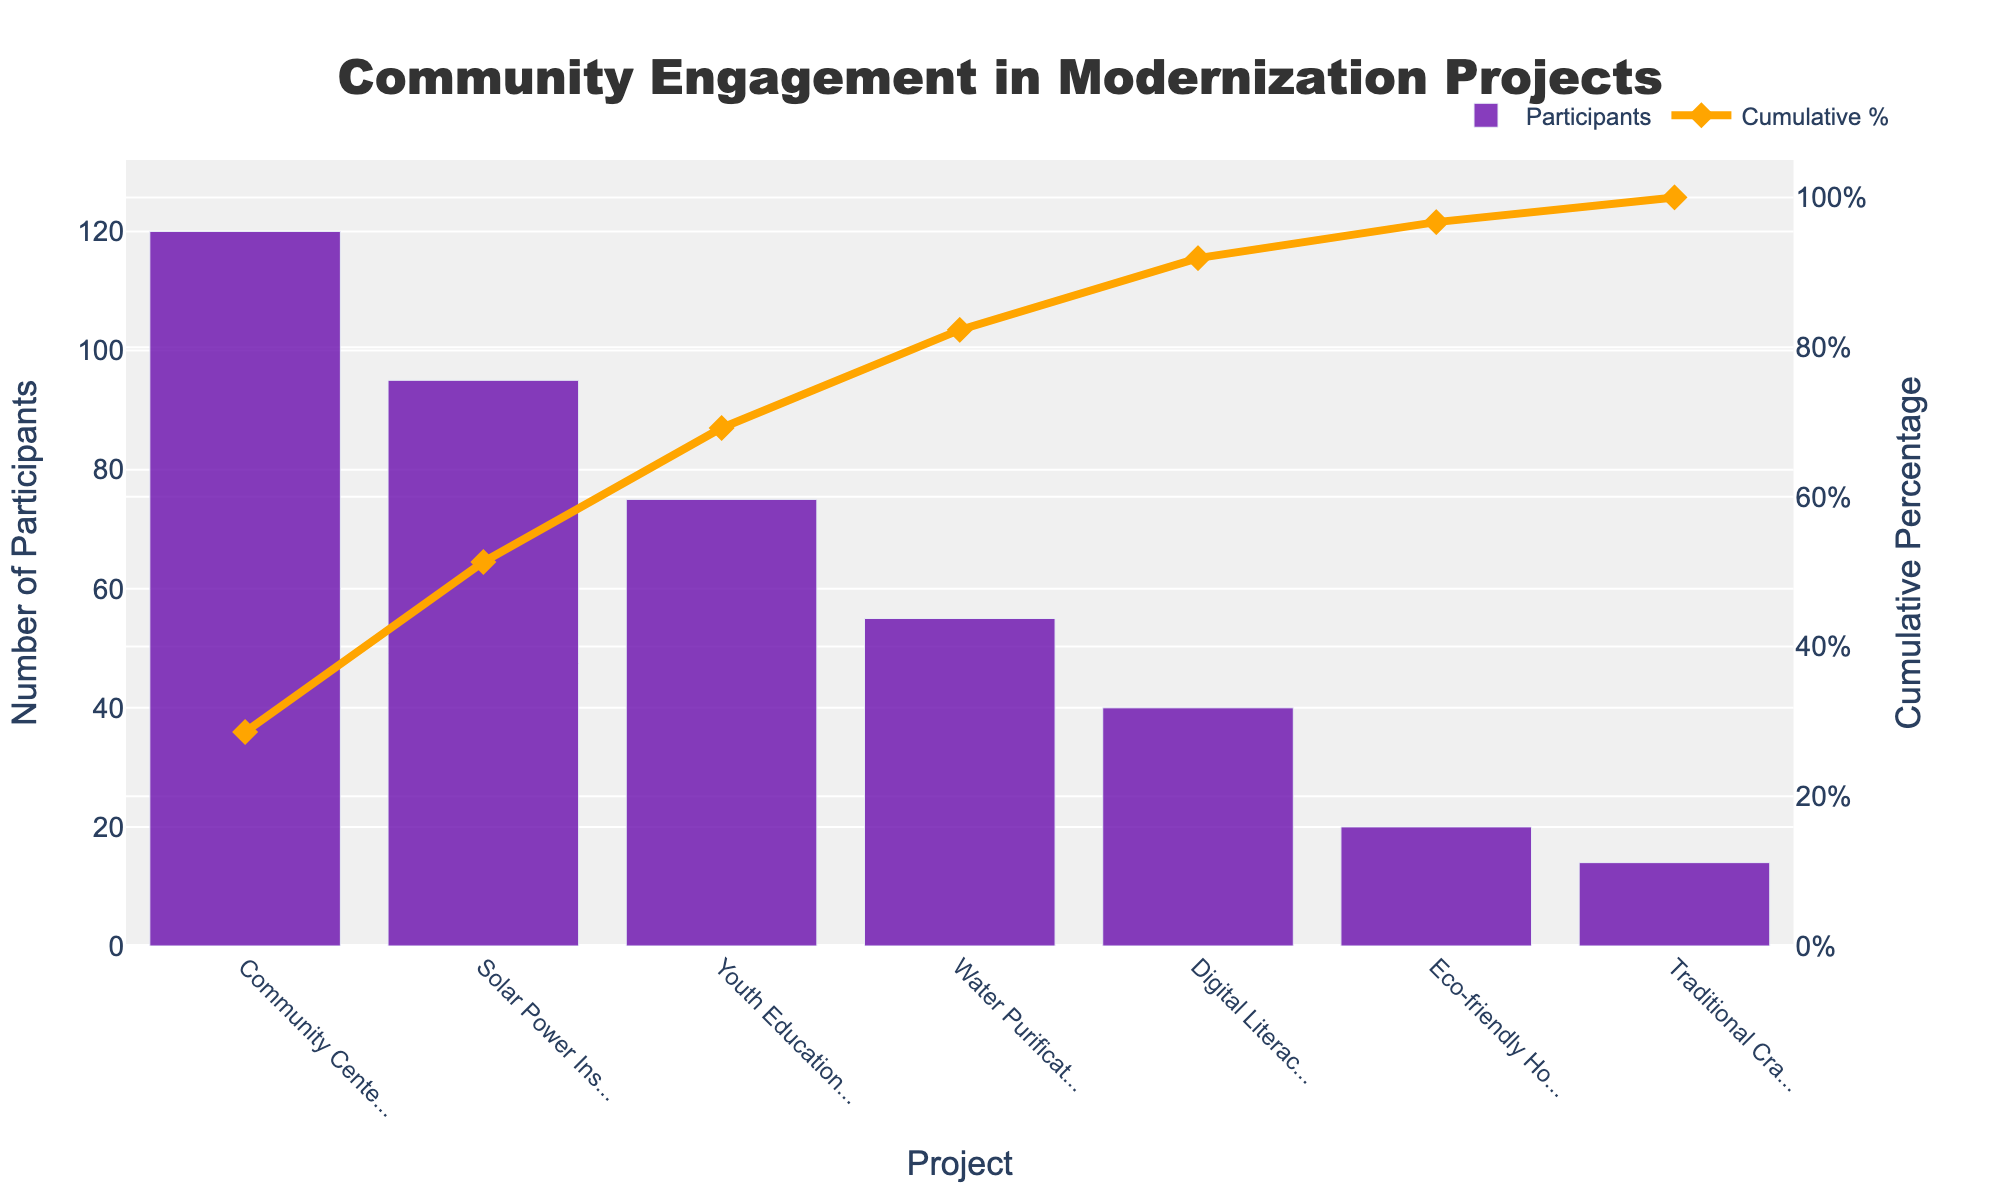What is the title of the chart? The title of the chart is typically found at the top and clearly indicates the subject of the visualization. Here, it reads "Community Engagement in Modernization Projects."
Answer: Community Engagement in Modernization Projects What is the project with the highest number of participants? Look for the tallest bar, which represents the project with the highest number of participants. The "Community Center Renovation" project has the tallest bar.
Answer: Community Center Renovation How many participants were involved in the Digital Literacy Workshop? Find the bar corresponding to the "Digital Literacy Workshop" and read the value on the y-axis. The bar shows 40 participants.
Answer: 40 What is the cumulative percentage after the Solar Power Installation project? Locate the "Solar Power Installation" point on the x-axis and check the value of the line plot for cumulative percentage at this point. The cumulative percentage is 51.3%.
Answer: 51.3% Which project has the lowest number of participants? Identify the shortest bar, representing the project with the lowest number of participants. The "Traditional Crafts Marketplace" has the shortest bar with 14 participants.
Answer: Traditional Crafts Marketplace What is the cumulative percentage for all projects combined? The final point of the cumulative percentage line represents the total cumulative percentage for all projects. Here, it reaches 100%.
Answer: 100% Which two projects combined have the highest number of participants, and what is their total number? Identify the two tallest bars, "Community Center Renovation" (120) and "Solar Power Installation" (95). Sum their participants: 120 + 95 = 215.
Answer: Community Center Renovation and Solar Power Installation, 215 What's the difference in participants between the Community Center Renovation and Water Purification System projects? Subtract the number of participants of the Water Purification System (55) from the Community Center Renovation (120): 120 - 55 = 65.
Answer: 65 What percentage of total participation is reached after the first three projects? Sum the cumulative percentages of the first three projects: 28.6% (Community Center Renovation) + 22.7% (Solar Power Installation) + 17.9% (Youth Education Program) = 69.2%.
Answer: 69.2% Which project marks the point at which the cumulative percentage surpasses 90%? Examine the cumulative percentage line and find the project after which this line exceeds 90%. It is right after the "Digital Literacy Workshop" project (91.9%).
Answer: Digital Literacy Workshop 